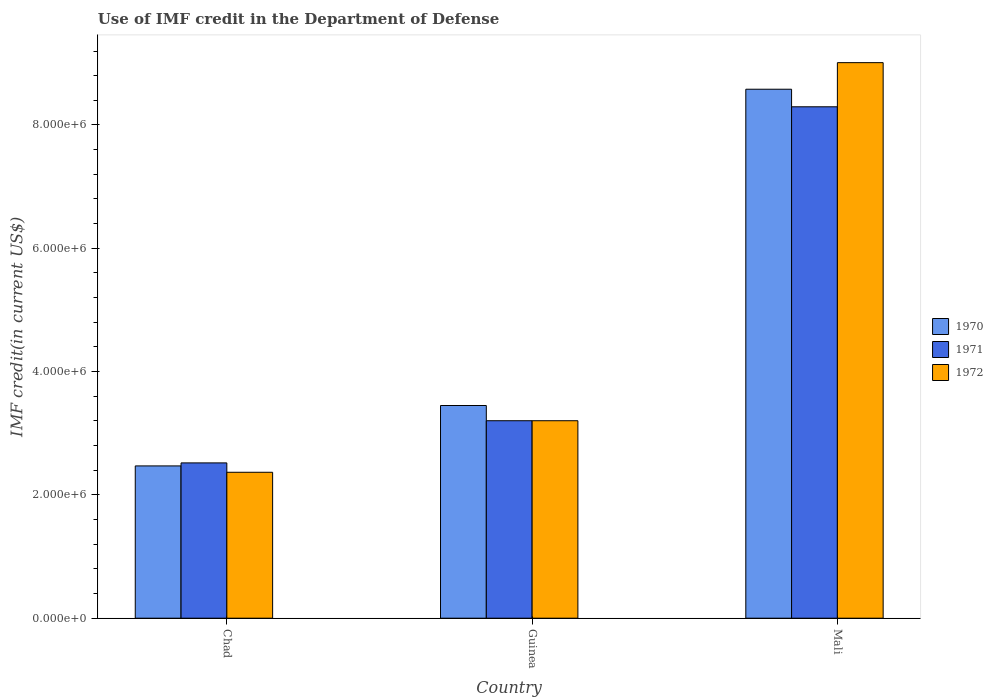How many different coloured bars are there?
Give a very brief answer. 3. How many groups of bars are there?
Make the answer very short. 3. Are the number of bars on each tick of the X-axis equal?
Your answer should be compact. Yes. How many bars are there on the 2nd tick from the left?
Provide a short and direct response. 3. How many bars are there on the 3rd tick from the right?
Provide a short and direct response. 3. What is the label of the 1st group of bars from the left?
Offer a very short reply. Chad. In how many cases, is the number of bars for a given country not equal to the number of legend labels?
Your answer should be compact. 0. What is the IMF credit in the Department of Defense in 1970 in Guinea?
Make the answer very short. 3.45e+06. Across all countries, what is the maximum IMF credit in the Department of Defense in 1970?
Your response must be concise. 8.58e+06. Across all countries, what is the minimum IMF credit in the Department of Defense in 1970?
Give a very brief answer. 2.47e+06. In which country was the IMF credit in the Department of Defense in 1970 maximum?
Make the answer very short. Mali. In which country was the IMF credit in the Department of Defense in 1971 minimum?
Your answer should be very brief. Chad. What is the total IMF credit in the Department of Defense in 1972 in the graph?
Make the answer very short. 1.46e+07. What is the difference between the IMF credit in the Department of Defense in 1972 in Chad and that in Mali?
Offer a terse response. -6.64e+06. What is the difference between the IMF credit in the Department of Defense in 1970 in Chad and the IMF credit in the Department of Defense in 1971 in Guinea?
Your answer should be very brief. -7.33e+05. What is the average IMF credit in the Department of Defense in 1971 per country?
Your answer should be compact. 4.67e+06. What is the difference between the IMF credit in the Department of Defense of/in 1970 and IMF credit in the Department of Defense of/in 1972 in Chad?
Keep it short and to the point. 1.03e+05. In how many countries, is the IMF credit in the Department of Defense in 1970 greater than 6000000 US$?
Make the answer very short. 1. What is the ratio of the IMF credit in the Department of Defense in 1971 in Guinea to that in Mali?
Your answer should be compact. 0.39. What is the difference between the highest and the second highest IMF credit in the Department of Defense in 1972?
Your answer should be compact. 6.64e+06. What is the difference between the highest and the lowest IMF credit in the Department of Defense in 1970?
Provide a succinct answer. 6.11e+06. Is the sum of the IMF credit in the Department of Defense in 1972 in Guinea and Mali greater than the maximum IMF credit in the Department of Defense in 1970 across all countries?
Your answer should be compact. Yes. What does the 3rd bar from the left in Chad represents?
Make the answer very short. 1972. What does the 1st bar from the right in Chad represents?
Your response must be concise. 1972. How many bars are there?
Ensure brevity in your answer.  9. Are all the bars in the graph horizontal?
Your response must be concise. No. Does the graph contain any zero values?
Offer a terse response. No. Does the graph contain grids?
Make the answer very short. No. Where does the legend appear in the graph?
Your response must be concise. Center right. How are the legend labels stacked?
Your answer should be compact. Vertical. What is the title of the graph?
Give a very brief answer. Use of IMF credit in the Department of Defense. What is the label or title of the X-axis?
Your answer should be very brief. Country. What is the label or title of the Y-axis?
Ensure brevity in your answer.  IMF credit(in current US$). What is the IMF credit(in current US$) in 1970 in Chad?
Keep it short and to the point. 2.47e+06. What is the IMF credit(in current US$) of 1971 in Chad?
Make the answer very short. 2.52e+06. What is the IMF credit(in current US$) of 1972 in Chad?
Offer a terse response. 2.37e+06. What is the IMF credit(in current US$) in 1970 in Guinea?
Give a very brief answer. 3.45e+06. What is the IMF credit(in current US$) in 1971 in Guinea?
Offer a terse response. 3.20e+06. What is the IMF credit(in current US$) of 1972 in Guinea?
Your response must be concise. 3.20e+06. What is the IMF credit(in current US$) of 1970 in Mali?
Provide a succinct answer. 8.58e+06. What is the IMF credit(in current US$) in 1971 in Mali?
Make the answer very short. 8.30e+06. What is the IMF credit(in current US$) in 1972 in Mali?
Ensure brevity in your answer.  9.01e+06. Across all countries, what is the maximum IMF credit(in current US$) of 1970?
Give a very brief answer. 8.58e+06. Across all countries, what is the maximum IMF credit(in current US$) in 1971?
Give a very brief answer. 8.30e+06. Across all countries, what is the maximum IMF credit(in current US$) of 1972?
Offer a terse response. 9.01e+06. Across all countries, what is the minimum IMF credit(in current US$) of 1970?
Your answer should be very brief. 2.47e+06. Across all countries, what is the minimum IMF credit(in current US$) in 1971?
Provide a short and direct response. 2.52e+06. Across all countries, what is the minimum IMF credit(in current US$) in 1972?
Offer a very short reply. 2.37e+06. What is the total IMF credit(in current US$) in 1970 in the graph?
Provide a short and direct response. 1.45e+07. What is the total IMF credit(in current US$) of 1971 in the graph?
Provide a short and direct response. 1.40e+07. What is the total IMF credit(in current US$) in 1972 in the graph?
Give a very brief answer. 1.46e+07. What is the difference between the IMF credit(in current US$) in 1970 in Chad and that in Guinea?
Ensure brevity in your answer.  -9.80e+05. What is the difference between the IMF credit(in current US$) in 1971 in Chad and that in Guinea?
Your answer should be compact. -6.84e+05. What is the difference between the IMF credit(in current US$) of 1972 in Chad and that in Guinea?
Provide a short and direct response. -8.36e+05. What is the difference between the IMF credit(in current US$) in 1970 in Chad and that in Mali?
Provide a short and direct response. -6.11e+06. What is the difference between the IMF credit(in current US$) in 1971 in Chad and that in Mali?
Give a very brief answer. -5.78e+06. What is the difference between the IMF credit(in current US$) in 1972 in Chad and that in Mali?
Keep it short and to the point. -6.64e+06. What is the difference between the IMF credit(in current US$) of 1970 in Guinea and that in Mali?
Provide a short and direct response. -5.13e+06. What is the difference between the IMF credit(in current US$) of 1971 in Guinea and that in Mali?
Provide a short and direct response. -5.09e+06. What is the difference between the IMF credit(in current US$) in 1972 in Guinea and that in Mali?
Your response must be concise. -5.81e+06. What is the difference between the IMF credit(in current US$) of 1970 in Chad and the IMF credit(in current US$) of 1971 in Guinea?
Ensure brevity in your answer.  -7.33e+05. What is the difference between the IMF credit(in current US$) in 1970 in Chad and the IMF credit(in current US$) in 1972 in Guinea?
Provide a succinct answer. -7.33e+05. What is the difference between the IMF credit(in current US$) of 1971 in Chad and the IMF credit(in current US$) of 1972 in Guinea?
Ensure brevity in your answer.  -6.84e+05. What is the difference between the IMF credit(in current US$) of 1970 in Chad and the IMF credit(in current US$) of 1971 in Mali?
Provide a succinct answer. -5.82e+06. What is the difference between the IMF credit(in current US$) in 1970 in Chad and the IMF credit(in current US$) in 1972 in Mali?
Make the answer very short. -6.54e+06. What is the difference between the IMF credit(in current US$) in 1971 in Chad and the IMF credit(in current US$) in 1972 in Mali?
Ensure brevity in your answer.  -6.49e+06. What is the difference between the IMF credit(in current US$) in 1970 in Guinea and the IMF credit(in current US$) in 1971 in Mali?
Your response must be concise. -4.84e+06. What is the difference between the IMF credit(in current US$) in 1970 in Guinea and the IMF credit(in current US$) in 1972 in Mali?
Give a very brief answer. -5.56e+06. What is the difference between the IMF credit(in current US$) of 1971 in Guinea and the IMF credit(in current US$) of 1972 in Mali?
Give a very brief answer. -5.81e+06. What is the average IMF credit(in current US$) in 1970 per country?
Your answer should be compact. 4.83e+06. What is the average IMF credit(in current US$) in 1971 per country?
Offer a terse response. 4.67e+06. What is the average IMF credit(in current US$) of 1972 per country?
Offer a terse response. 4.86e+06. What is the difference between the IMF credit(in current US$) of 1970 and IMF credit(in current US$) of 1971 in Chad?
Provide a succinct answer. -4.90e+04. What is the difference between the IMF credit(in current US$) in 1970 and IMF credit(in current US$) in 1972 in Chad?
Provide a short and direct response. 1.03e+05. What is the difference between the IMF credit(in current US$) in 1971 and IMF credit(in current US$) in 1972 in Chad?
Provide a short and direct response. 1.52e+05. What is the difference between the IMF credit(in current US$) in 1970 and IMF credit(in current US$) in 1971 in Guinea?
Make the answer very short. 2.47e+05. What is the difference between the IMF credit(in current US$) in 1970 and IMF credit(in current US$) in 1972 in Guinea?
Make the answer very short. 2.47e+05. What is the difference between the IMF credit(in current US$) in 1971 and IMF credit(in current US$) in 1972 in Guinea?
Offer a very short reply. 0. What is the difference between the IMF credit(in current US$) of 1970 and IMF credit(in current US$) of 1971 in Mali?
Your response must be concise. 2.85e+05. What is the difference between the IMF credit(in current US$) of 1970 and IMF credit(in current US$) of 1972 in Mali?
Keep it short and to the point. -4.31e+05. What is the difference between the IMF credit(in current US$) in 1971 and IMF credit(in current US$) in 1972 in Mali?
Offer a very short reply. -7.16e+05. What is the ratio of the IMF credit(in current US$) of 1970 in Chad to that in Guinea?
Provide a short and direct response. 0.72. What is the ratio of the IMF credit(in current US$) in 1971 in Chad to that in Guinea?
Make the answer very short. 0.79. What is the ratio of the IMF credit(in current US$) of 1972 in Chad to that in Guinea?
Provide a short and direct response. 0.74. What is the ratio of the IMF credit(in current US$) of 1970 in Chad to that in Mali?
Provide a short and direct response. 0.29. What is the ratio of the IMF credit(in current US$) of 1971 in Chad to that in Mali?
Your response must be concise. 0.3. What is the ratio of the IMF credit(in current US$) in 1972 in Chad to that in Mali?
Provide a succinct answer. 0.26. What is the ratio of the IMF credit(in current US$) in 1970 in Guinea to that in Mali?
Your answer should be very brief. 0.4. What is the ratio of the IMF credit(in current US$) of 1971 in Guinea to that in Mali?
Your answer should be compact. 0.39. What is the ratio of the IMF credit(in current US$) of 1972 in Guinea to that in Mali?
Offer a terse response. 0.36. What is the difference between the highest and the second highest IMF credit(in current US$) in 1970?
Ensure brevity in your answer.  5.13e+06. What is the difference between the highest and the second highest IMF credit(in current US$) of 1971?
Offer a terse response. 5.09e+06. What is the difference between the highest and the second highest IMF credit(in current US$) in 1972?
Provide a short and direct response. 5.81e+06. What is the difference between the highest and the lowest IMF credit(in current US$) of 1970?
Your answer should be very brief. 6.11e+06. What is the difference between the highest and the lowest IMF credit(in current US$) of 1971?
Offer a terse response. 5.78e+06. What is the difference between the highest and the lowest IMF credit(in current US$) in 1972?
Keep it short and to the point. 6.64e+06. 